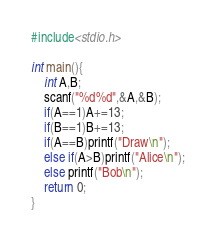<code> <loc_0><loc_0><loc_500><loc_500><_C_>#include<stdio.h>

int main(){
	int A,B;
	scanf("%d%d",&A,&B);
	if(A==1)A+=13;
	if(B==1)B+=13;
	if(A==B)printf("Draw\n");
	else if(A>B)printf("Alice\n");
	else printf("Bob\n");
	return 0;
}</code> 